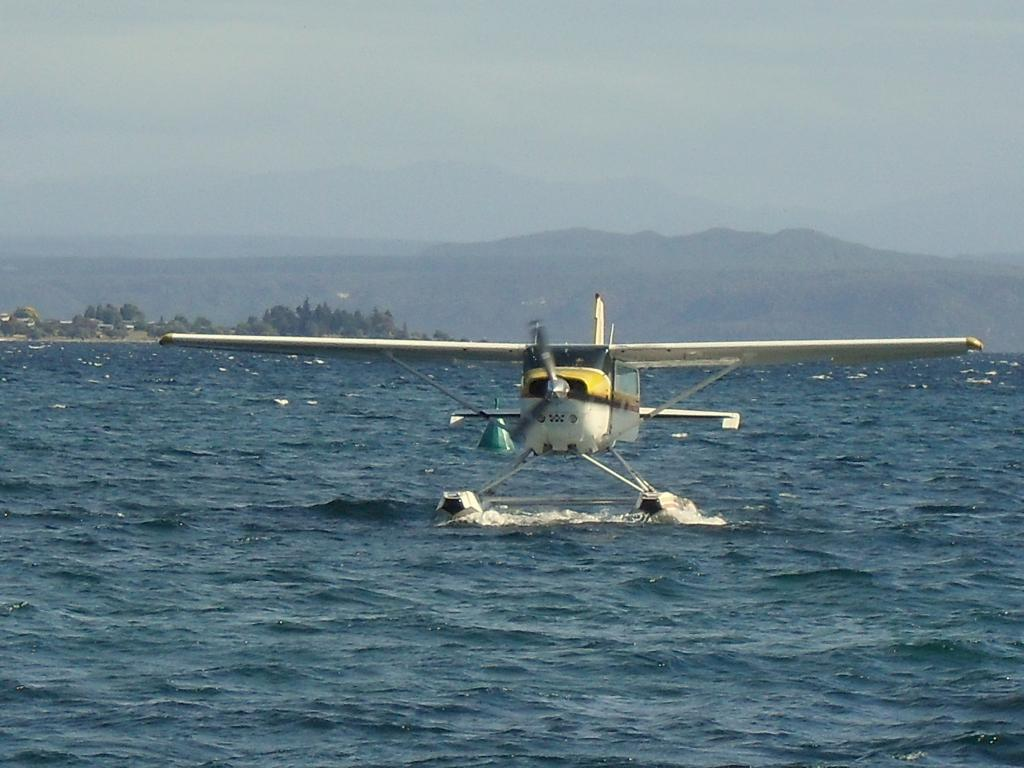What is the main subject of the image? The main subject of the image is an airplane. Where is the airplane located in the image? The airplane is on the water. What can be seen in the background of the image? There are mountains, trees, and the sky visible in the background of the image. What type of button can be seen on the airplane in the image? There is no button visible on the airplane in the image. What stage of development is the airplane in the image? The image does not provide information about the development stage of the airplane. 